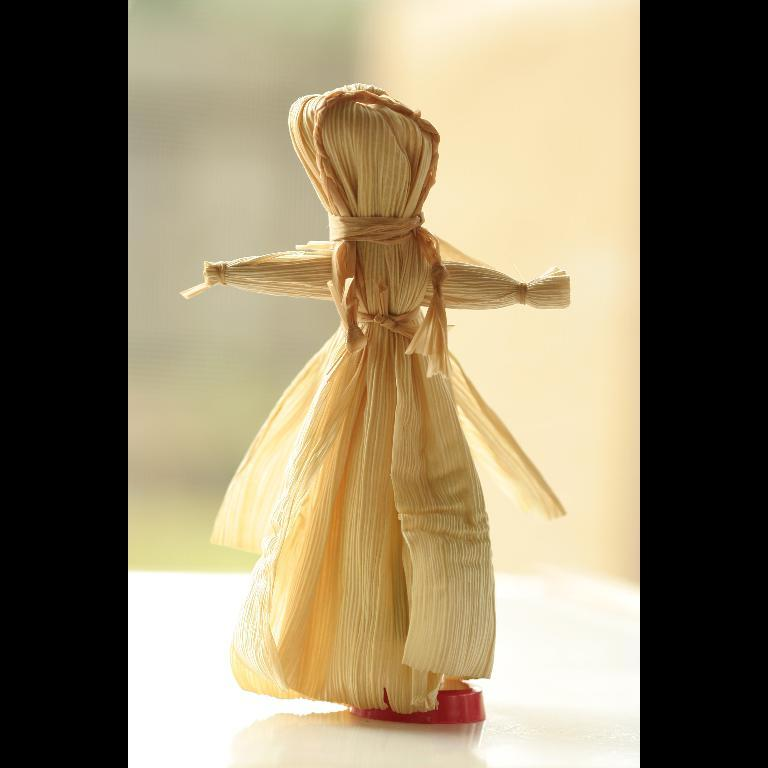What object is placed on the table in the image? There is a doll on the table in the image. Can you describe the background of the image? The background of the image is blurred. What type of hair can be seen on the doll in the image? There is no hair visible on the doll in the image, as it is a doll and does not have hair. 